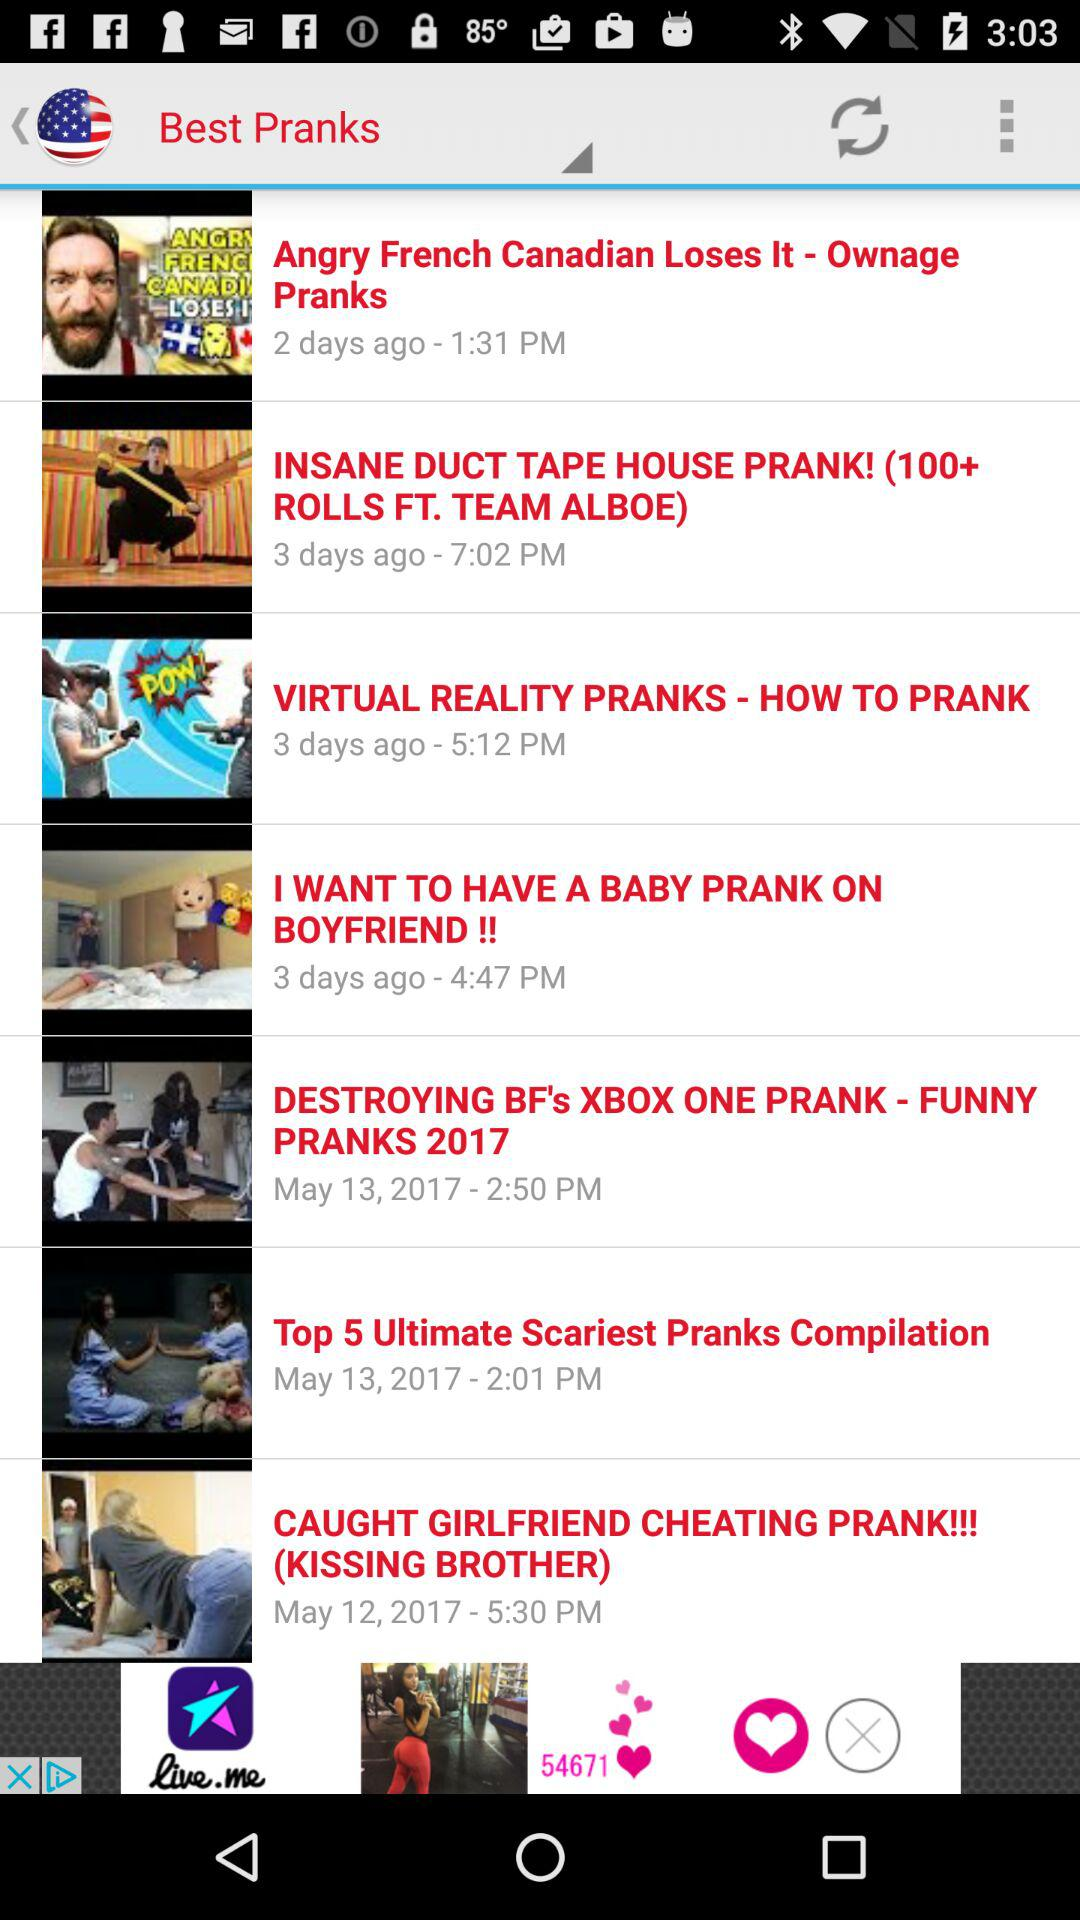How many pranks were uploaded on May 13, 2017?
Answer the question using a single word or phrase. 2 